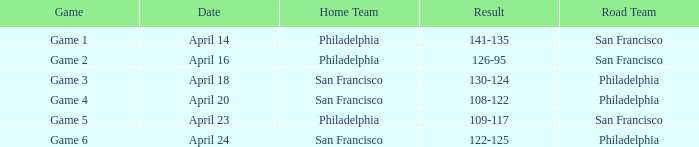Which game had a result of 126-95? Game 2. 